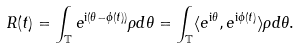<formula> <loc_0><loc_0><loc_500><loc_500>R ( t ) = \int _ { \mathbb { T } } e ^ { { \mathrm i } ( \theta - \phi ( t ) ) } \rho d \theta = \int _ { \mathbb { T } } \langle e ^ { { \mathrm i } \theta } , e ^ { { \mathrm i } \phi ( t ) } \rangle \rho d \theta .</formula> 